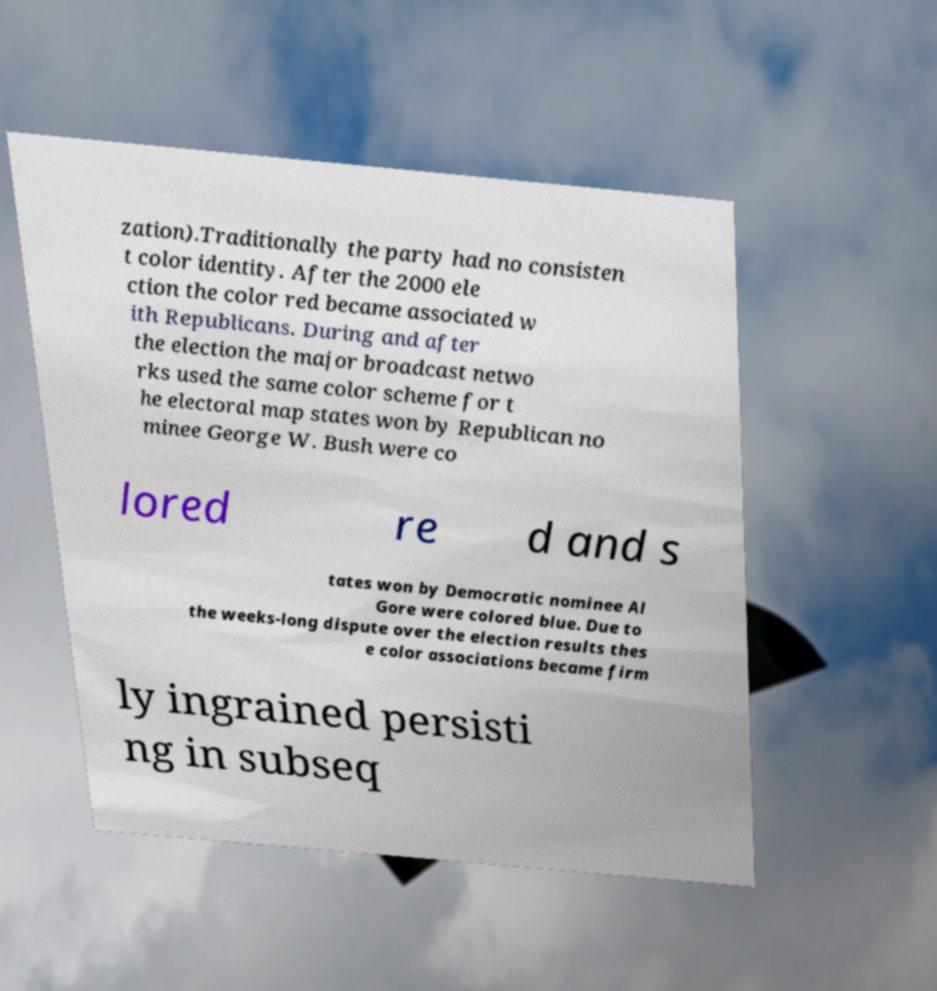Please read and relay the text visible in this image. What does it say? zation).Traditionally the party had no consisten t color identity. After the 2000 ele ction the color red became associated w ith Republicans. During and after the election the major broadcast netwo rks used the same color scheme for t he electoral map states won by Republican no minee George W. Bush were co lored re d and s tates won by Democratic nominee Al Gore were colored blue. Due to the weeks-long dispute over the election results thes e color associations became firm ly ingrained persisti ng in subseq 